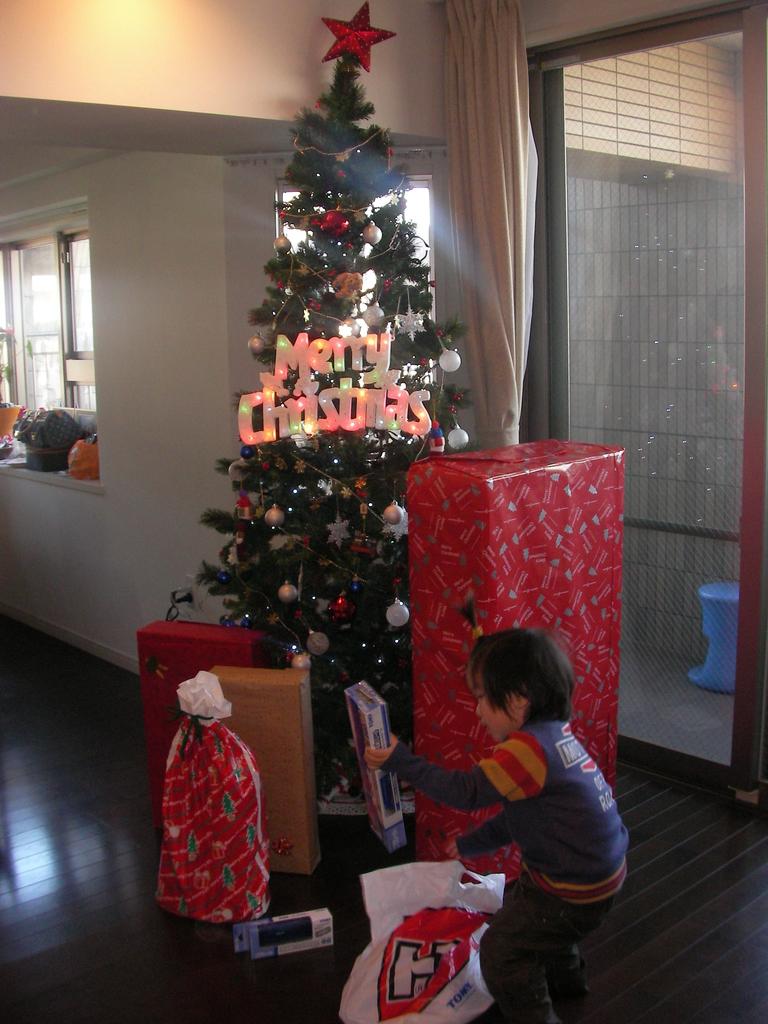What holiday season is celebrated with the lights?
Your response must be concise. Christmas. What letter is on the bag?
Your answer should be compact. H. 